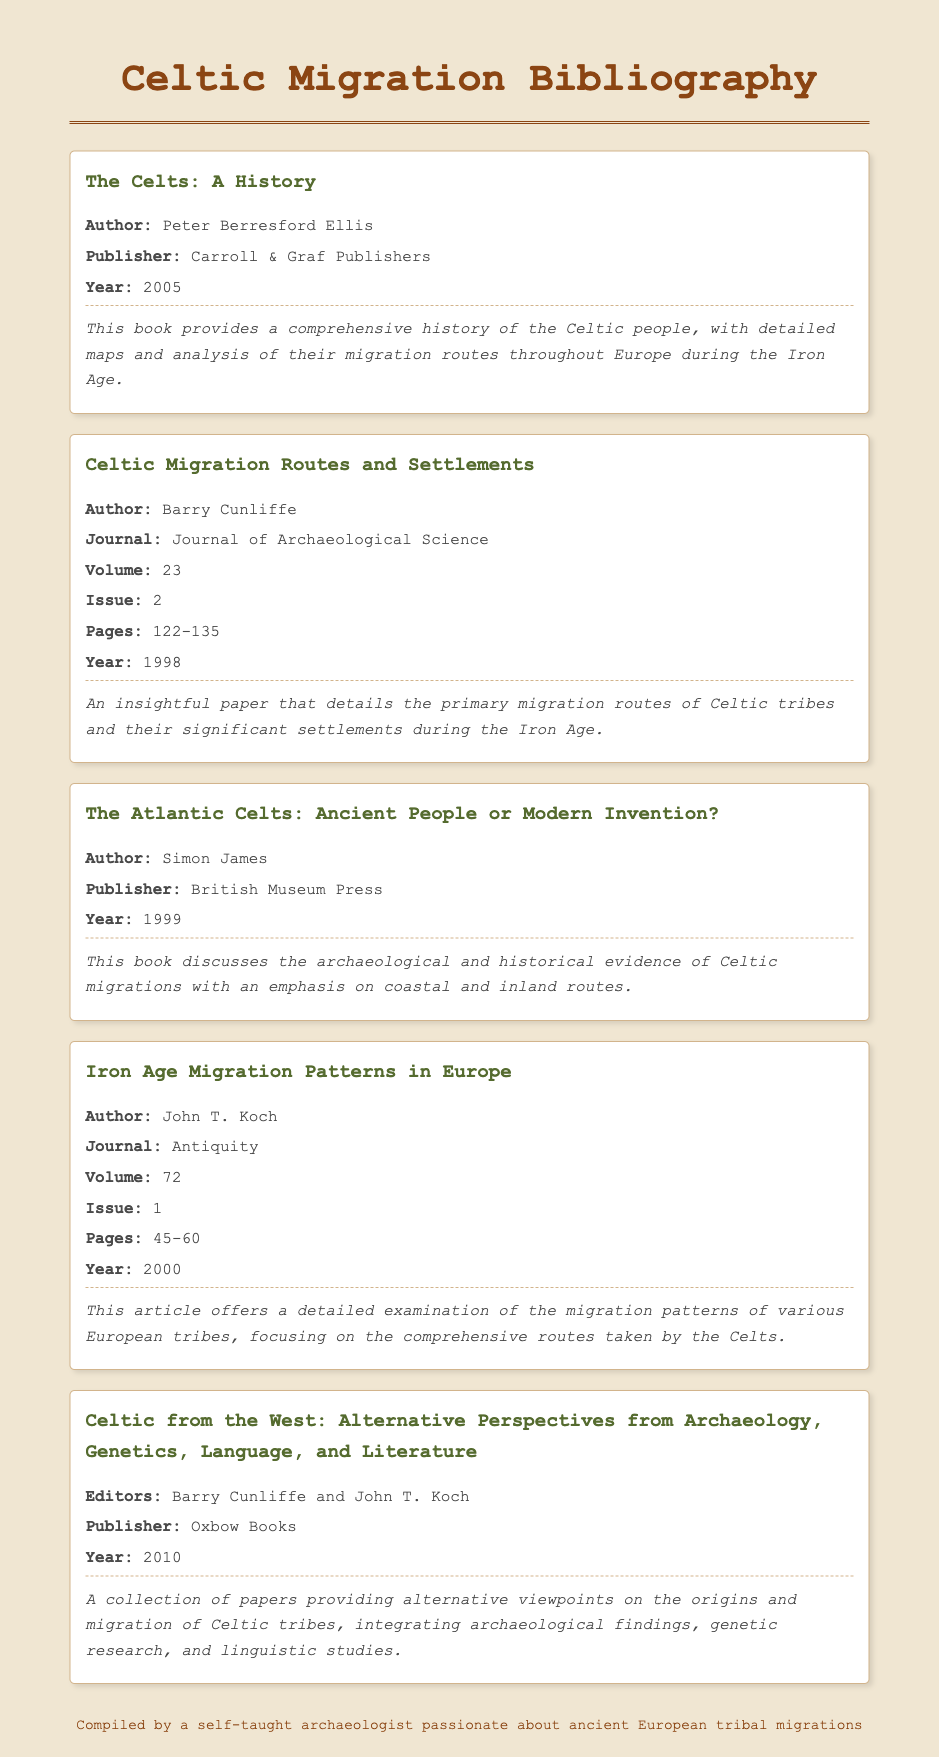What is the title of the first entry? The title of the first entry is listed at the top of the corresponding bibliography item.
Answer: The Celts: A History Who is the author of "Celtic Migration Routes and Settlements"? The author's name is explicitly mentioned below the title of the entry.
Answer: Barry Cunliffe What year was "The Atlantic Celts: Ancient People or Modern Invention?" published? The publication year is provided within the bibliography item for that book.
Answer: 1999 How many pages does the article "Iron Age Migration Patterns in Europe" span? The span of pages is specified within the bibliographic citation of the article.
Answer: 45-60 What is the name of the publishing house for "Celtic from the West"? The publishing information for the collection is included in the citation just below the title.
Answer: Oxbow Books Who are the editors of the last bibliography item? The editors are mentioned in a key position in the bibliographic entry for the last item.
Answer: Barry Cunliffe and John T. Koch What topic does Peter Berresford Ellis focus on in his book? The notes section under the bibliography item offers a brief overview of the book's content.
Answer: Celtic people and migration routes How many entries in total are included in the bibliography? Count the number of separate bibliography items listed in the document.
Answer: Five What kind of resource is "Iron Age Migration Patterns in Europe"? The bibliographic entry specifies the type of resource for this entry directly after the author's name.
Answer: Journal article What is the primary focus of the journal article by Barry Cunliffe? The notes provide insight into the main focus of the article.
Answer: Migration routes and settlements 